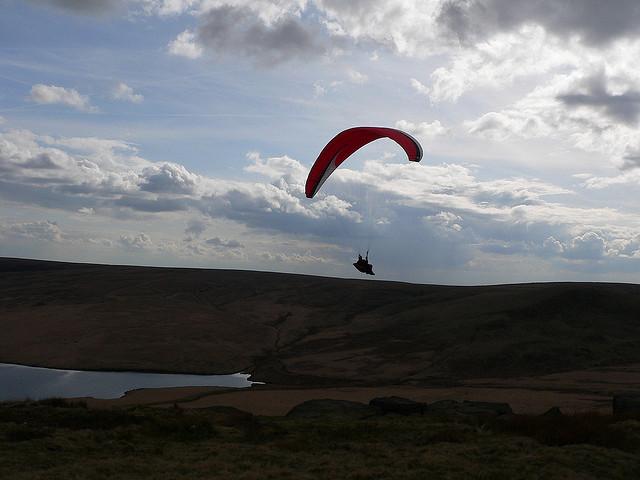Is the sky clear?
Short answer required. No. Does this area appear to be remote?
Answer briefly. Yes. Did this person parachute from a plane?
Short answer required. Yes. 